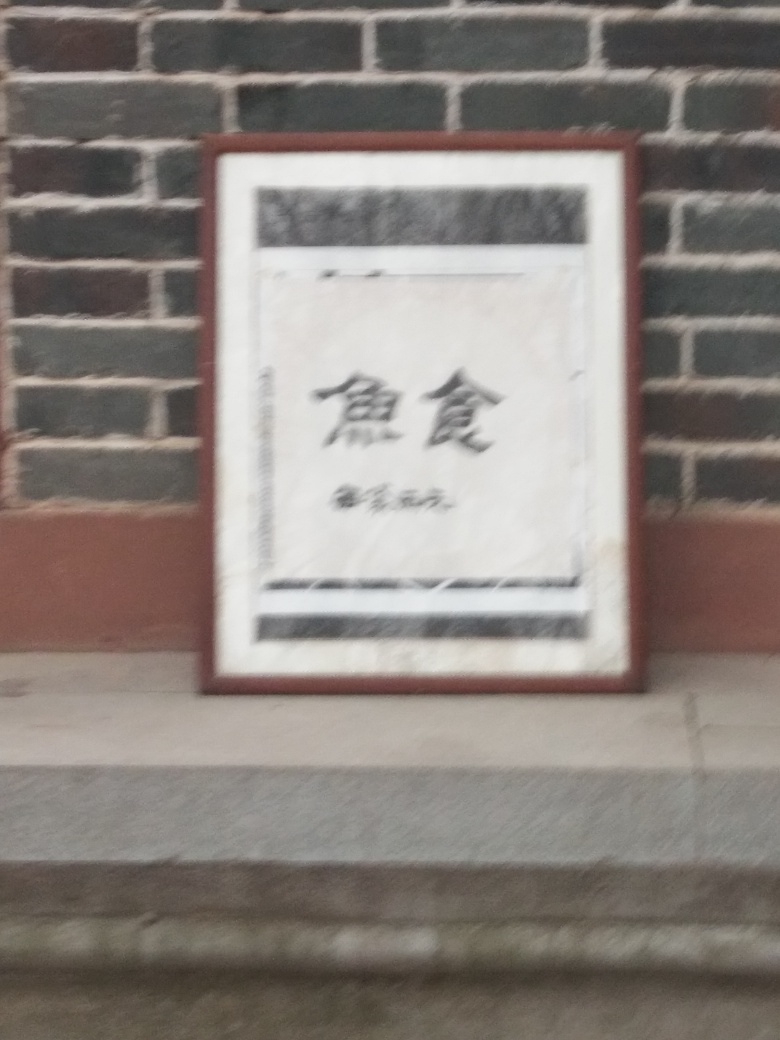What can be improved to make this image more visually appealing? To improve the visual appeal, the image should be taken with a steady hand or a tripod to avoid blurriness. Proper lighting and focus on the sign can also enhance its clarity. Additionally, experimenting with different angles and compositions could elevate the overall aesthetic of the photo. 